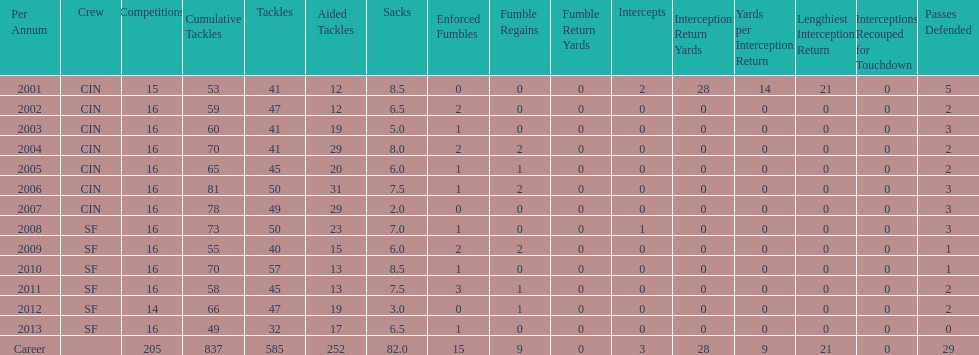What is the typical number of tackles this player has had during his career? 45. 